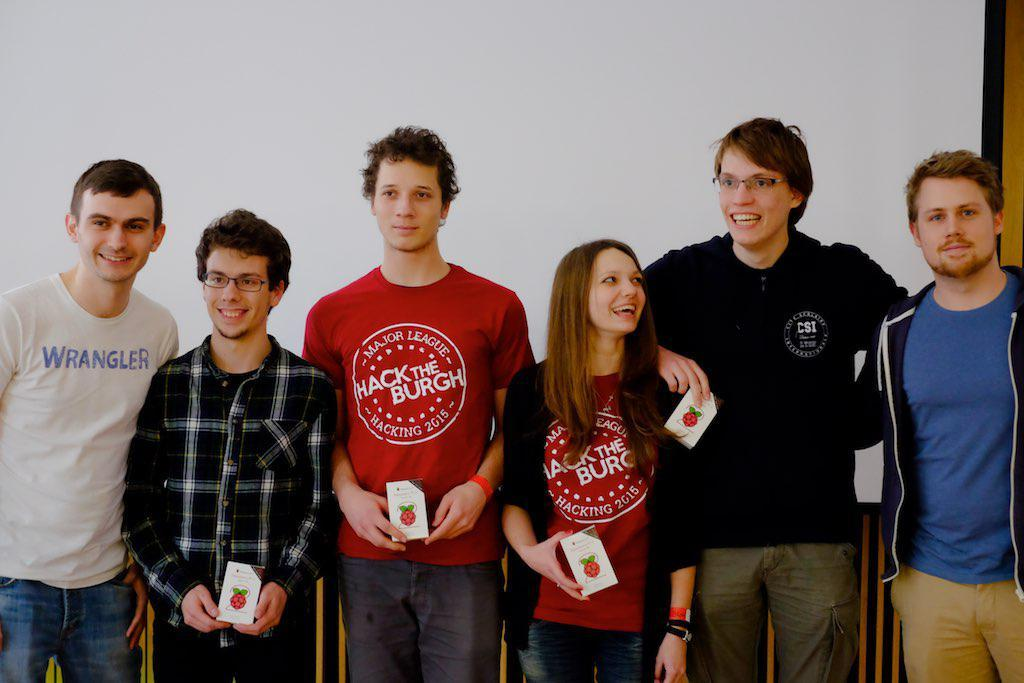<image>
Offer a succinct explanation of the picture presented. Men standing in a row with a man wearing a red shirt which says "Hack THe Burgh". 